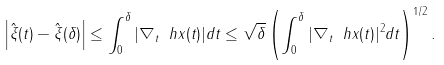<formula> <loc_0><loc_0><loc_500><loc_500>\left | \hat { \xi } ( t ) - \hat { \xi } ( \delta ) \right | \leq \int _ { 0 } ^ { \delta } | \nabla _ { t } \ h x ( t ) | d t \leq \sqrt { \delta } \left ( \int _ { 0 } ^ { \delta } | \nabla _ { t } \ h x ( t ) | ^ { 2 } d t \right ) ^ { 1 / 2 } .</formula> 